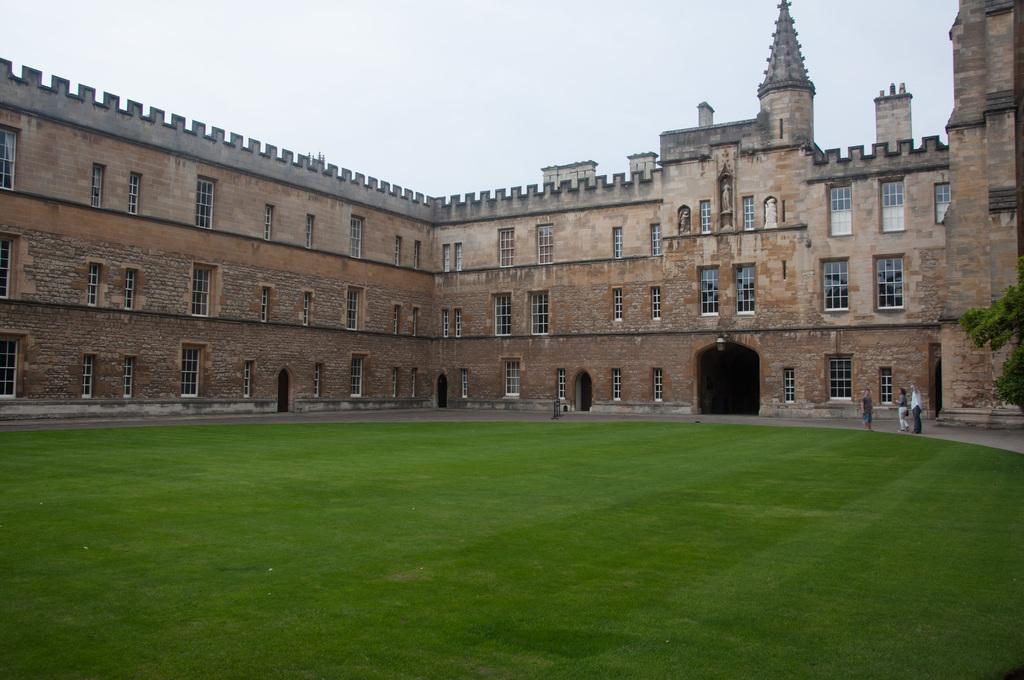Describe this image in one or two sentences. In the image there is a castle in the back with many windows all over it with grassland in front of it and above its sky. 